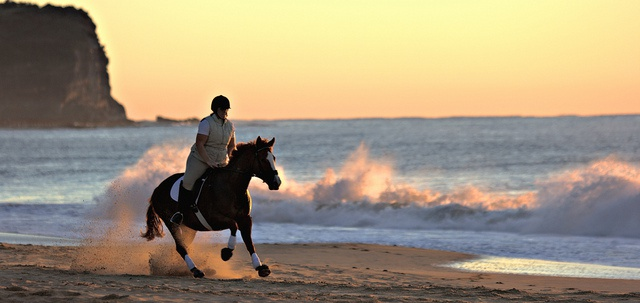Describe the objects in this image and their specific colors. I can see horse in khaki, black, gray, maroon, and brown tones and people in khaki, black, and gray tones in this image. 